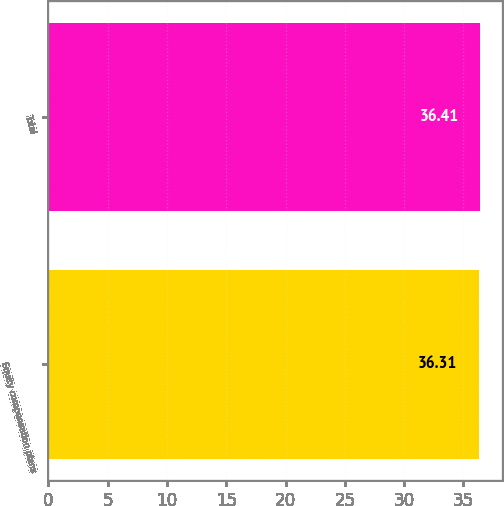Convert chart. <chart><loc_0><loc_0><loc_500><loc_500><bar_chart><fcel>Equity compensation plans<fcel>Total<nl><fcel>36.31<fcel>36.41<nl></chart> 